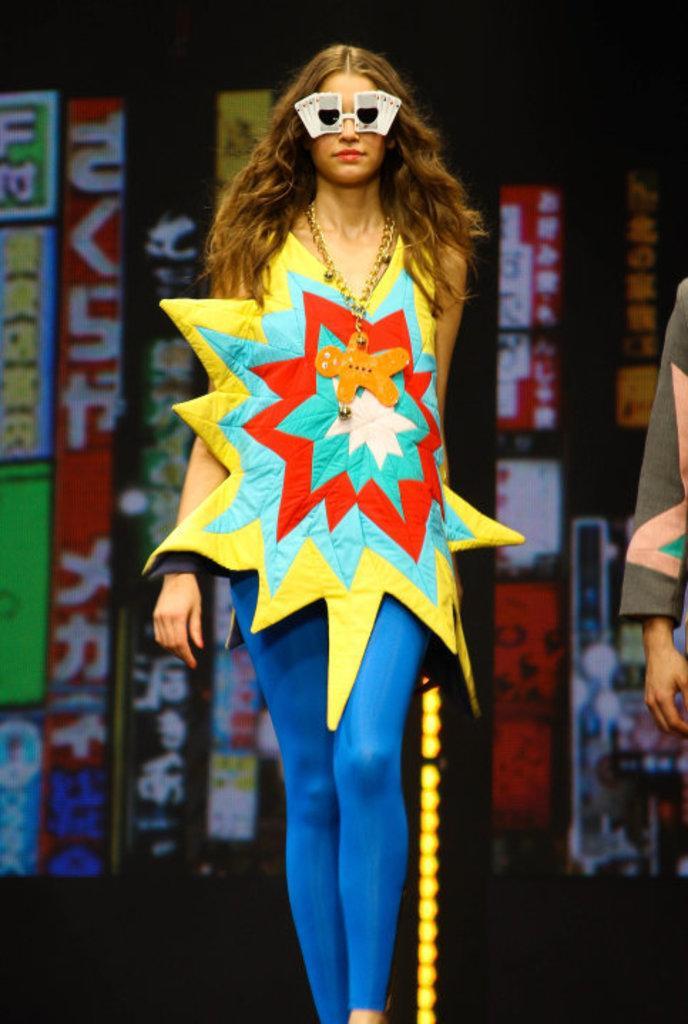Please provide a concise description of this image. In this image we can see a lady wearing goggles is walking. In the back there are banners. 